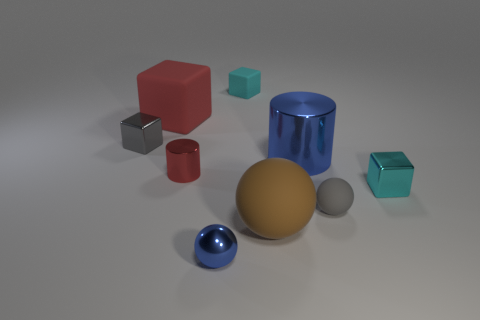What is the shape of the tiny shiny thing that is on the right side of the big matte ball?
Provide a short and direct response. Cube. Does the cyan block on the right side of the tiny cyan rubber object have the same material as the blue object that is behind the large brown thing?
Provide a succinct answer. Yes. Are there any gray rubber objects of the same shape as the big brown rubber object?
Your response must be concise. Yes. How many objects are cyan objects that are left of the tiny gray rubber object or tiny cyan rubber cubes?
Provide a succinct answer. 1. Is the number of metallic cubes in front of the large blue thing greater than the number of small blue things to the right of the large brown matte sphere?
Offer a very short reply. Yes. What number of metallic things are either big things or tiny gray cubes?
Your answer should be very brief. 2. What material is the small object that is the same color as the tiny matte cube?
Ensure brevity in your answer.  Metal. Is the number of large blue things that are on the right side of the small metal cylinder less than the number of red metallic things left of the small gray cube?
Give a very brief answer. No. What number of objects are either small cyan metallic cubes or matte objects to the left of the large brown object?
Ensure brevity in your answer.  3. What is the material of the gray thing that is the same size as the gray matte ball?
Offer a terse response. Metal. 